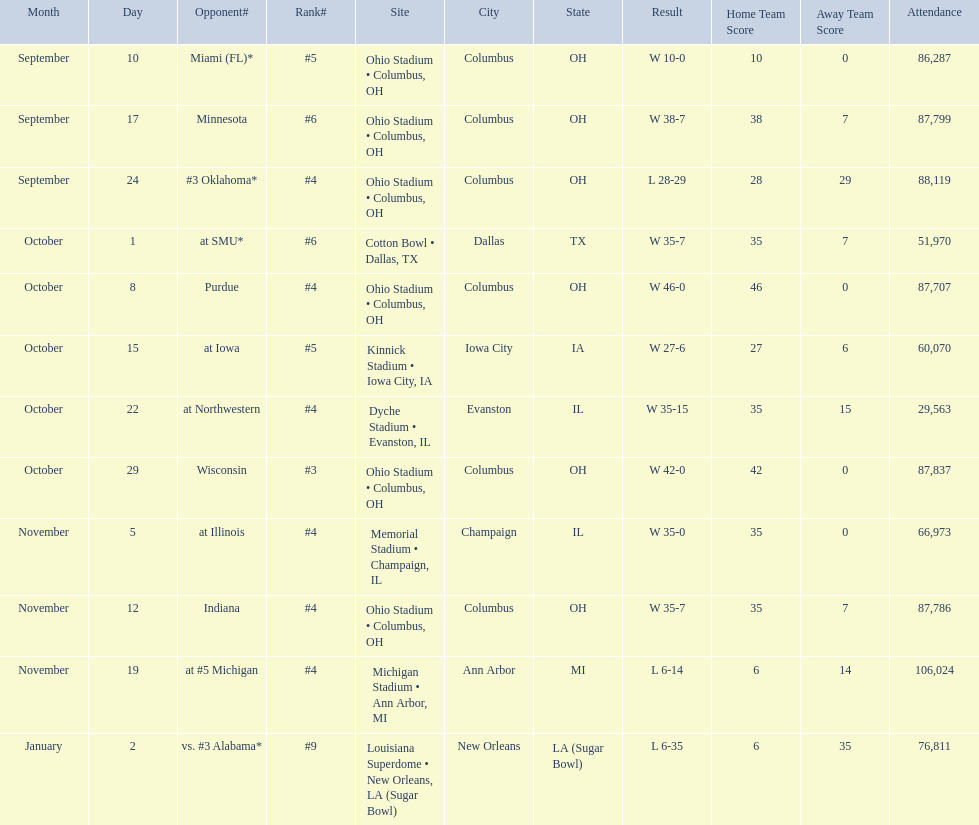Parse the full table. {'header': ['Month', 'Day', 'Opponent#', 'Rank#', 'Site', 'City', 'State', 'Result', 'Home Team Score', 'Away Team Score', 'Attendance'], 'rows': [['September', '10', 'Miami (FL)*', '#5', 'Ohio Stadium • Columbus, OH', 'Columbus', 'OH', 'W\xa010-0', '10', '0', '86,287'], ['September', '17', 'Minnesota', '#6', 'Ohio Stadium • Columbus, OH', 'Columbus', 'OH', 'W\xa038-7', '38', '7', '87,799'], ['September', '24', '#3\xa0Oklahoma*', '#4', 'Ohio Stadium • Columbus, OH', 'Columbus', 'OH', 'L\xa028-29', '28', '29', '88,119'], ['October', '1', 'at\xa0SMU*', '#6', 'Cotton Bowl • Dallas, TX', 'Dallas', 'TX', 'W\xa035-7', '35', '7', '51,970'], ['October', '8', 'Purdue', '#4', 'Ohio Stadium • Columbus, OH', 'Columbus', 'OH', 'W\xa046-0', '46', '0', '87,707'], ['October', '15', 'at\xa0Iowa', '#5', 'Kinnick Stadium • Iowa City, IA', 'Iowa City', 'IA', 'W\xa027-6', '27', '6', '60,070'], ['October', '22', 'at\xa0Northwestern', '#4', 'Dyche Stadium • Evanston, IL', 'Evanston', 'IL', 'W\xa035-15', '35', '15', '29,563'], ['October', '29', 'Wisconsin', '#3', 'Ohio Stadium • Columbus, OH', 'Columbus', 'OH', 'W\xa042-0', '42', '0', '87,837'], ['November', '5', 'at\xa0Illinois', '#4', 'Memorial Stadium • Champaign, IL', 'Champaign', 'IL', 'W\xa035-0', '35', '0', '66,973'], ['November', '12', 'Indiana', '#4', 'Ohio Stadium • Columbus, OH', 'Columbus', 'OH', 'W\xa035-7', '35', '7', '87,786'], ['November', '19', 'at\xa0#5\xa0Michigan', '#4', 'Michigan Stadium • Ann Arbor, MI', 'Ann Arbor', 'MI', 'L\xa06-14', '6', '14', '106,024'], ['January', '2', 'vs.\xa0#3\xa0Alabama*', '#9', 'Louisiana Superdome • New Orleans, LA (Sugar Bowl)', 'New Orleans', 'LA (Sugar Bowl)', 'L\xa06-35', '6', '35', '76,811']]} In how many games were than more than 80,000 people attending 7. 